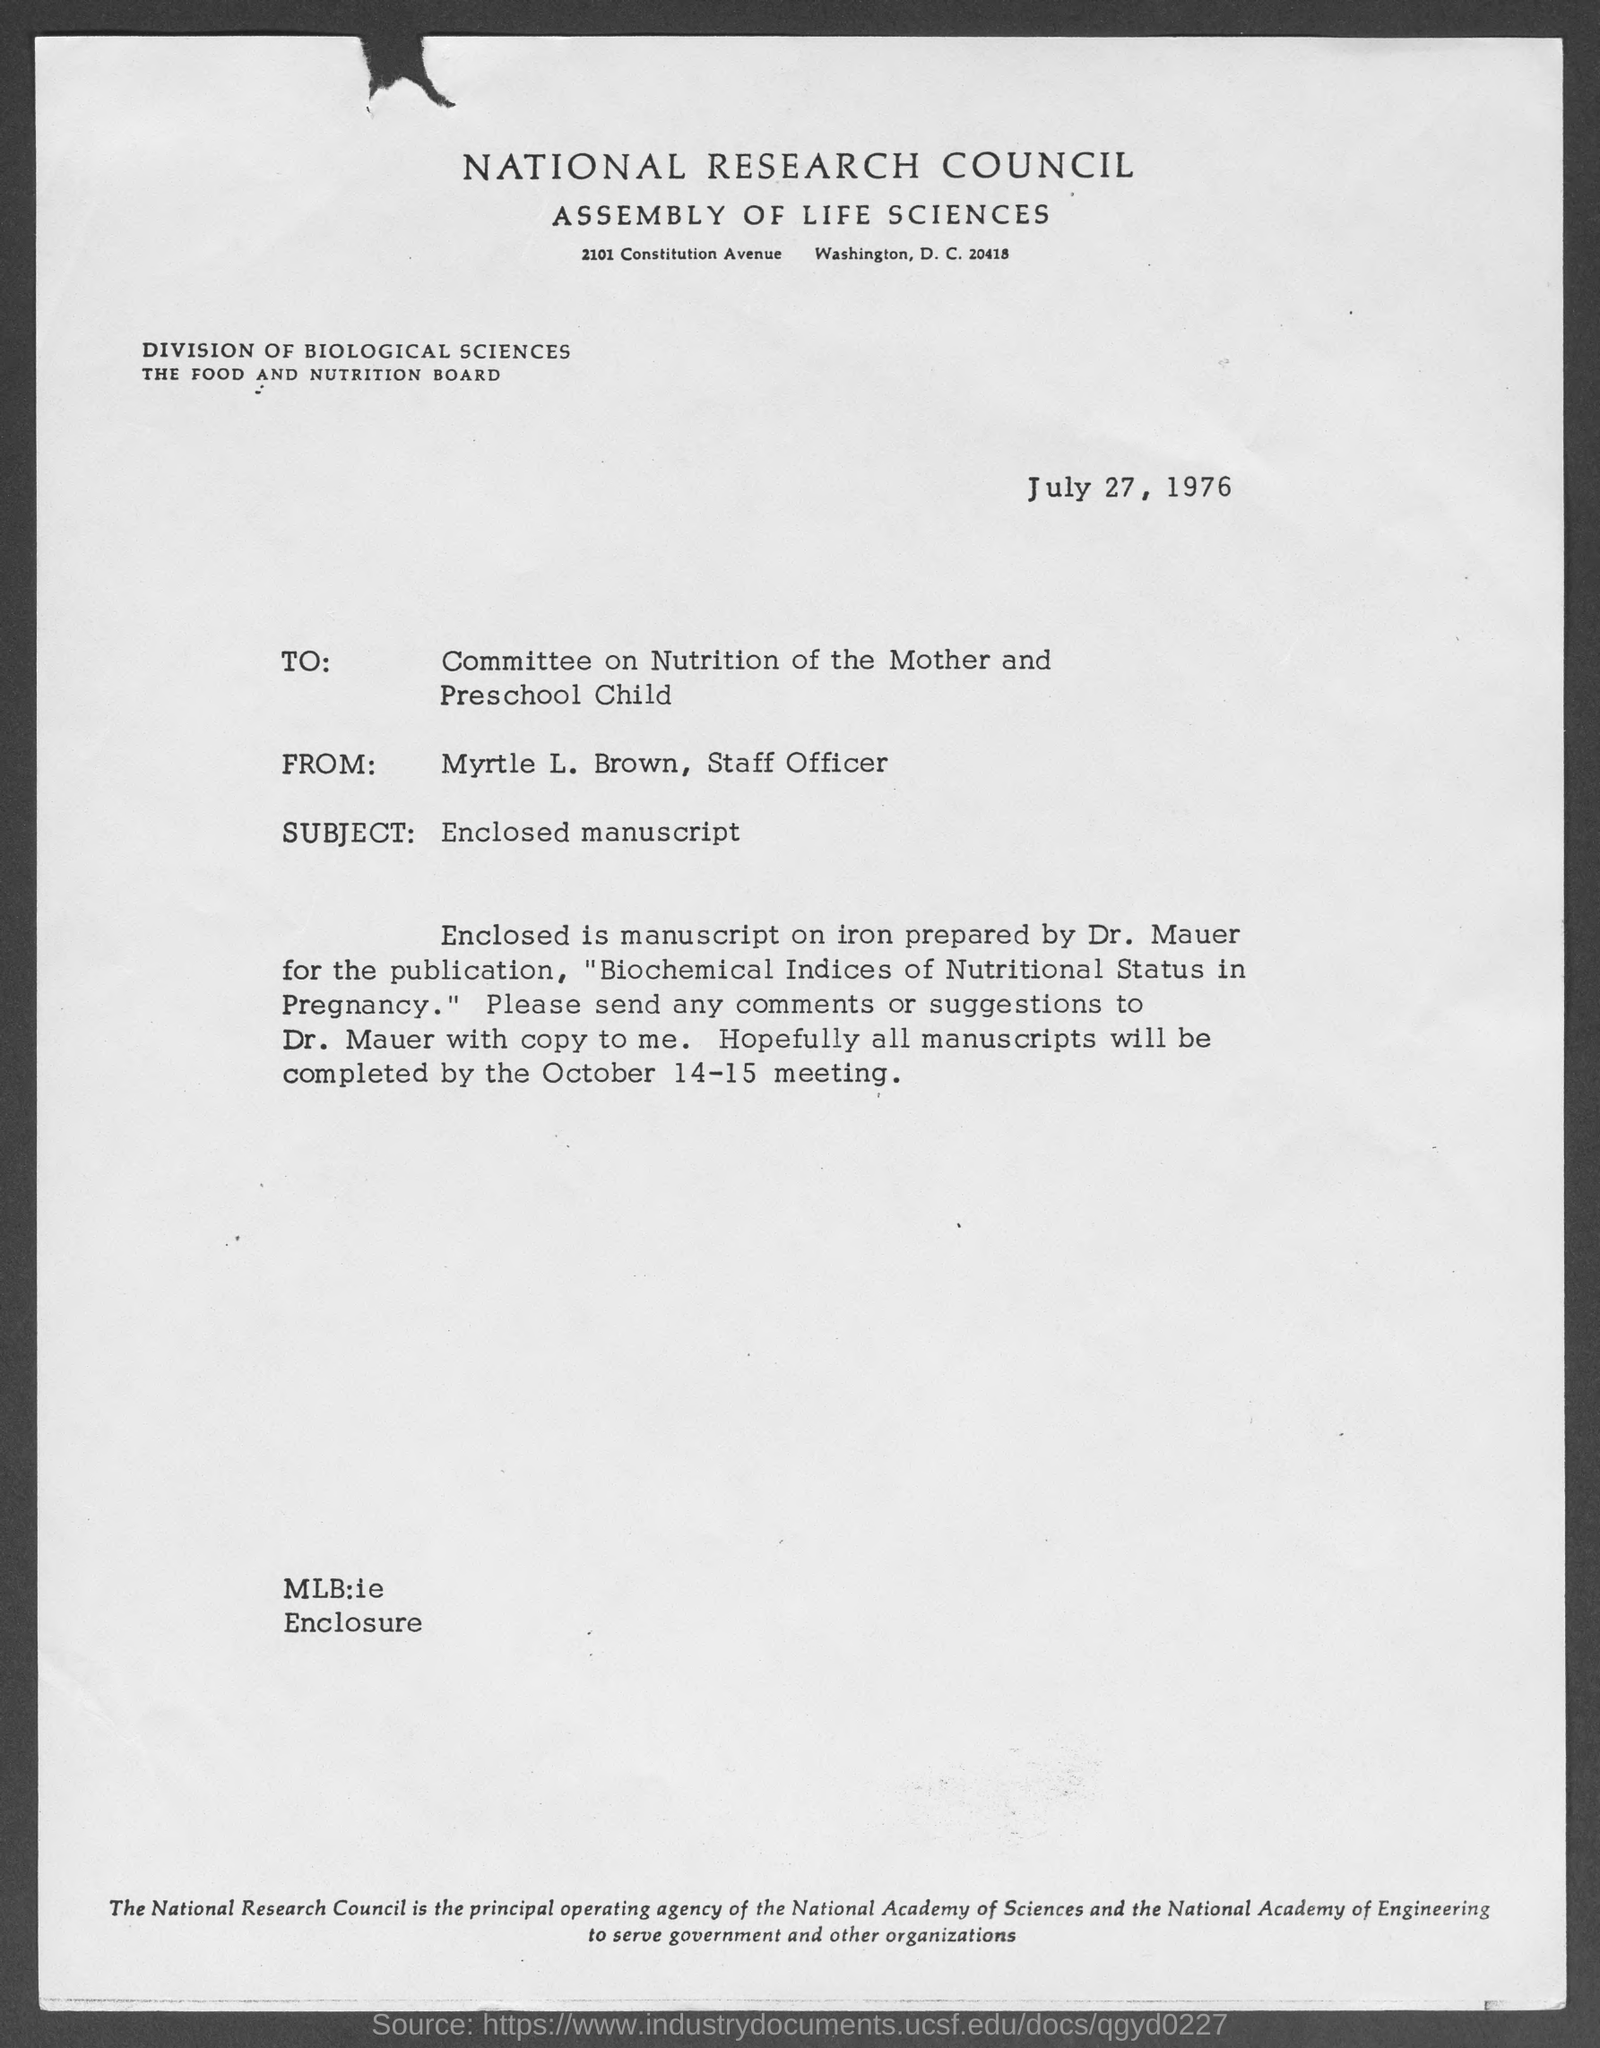What is the date of the document, and how might the date influence the context of its content? The document is dated July 27, 1976. During this time, nutritional science and public health policies were undergoing significant developments, which might have influenced the research priorities and findings discussed in the enclosed manuscript on nutritional status during pregnancy.  What might be the topic of the enclosed manuscript based on the information in the document? The manuscript focuses on iron and its biochemical indices of nutritional status in pregnancy, suggesting a detailed exploration of iron's role in prenatal nutrition and its potential impacts on both the mother and child during pregnancy. 